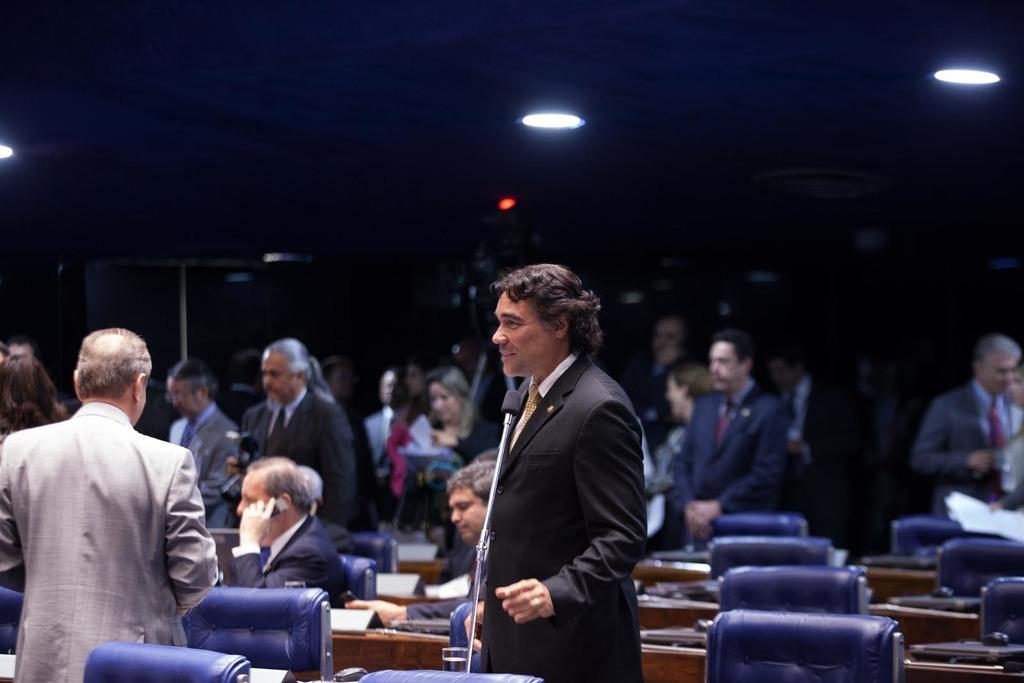How many groups of people can be seen in the image? There are two groups of people in the image, one standing and one sitting. What are the sitting people using to support themselves? The sitting people are on chairs. What objects are present on the tables in front of the sitting people? There are microphones on the tables. What might the people be doing in the image? The presence of microphones suggests that the sitting people might be participating in a discussion or presentation. How many boys are sitting on the edge of the table in the image? There are no boys sitting on the edge of the table in the image. What type of crack can be heard in the background of the image? There is no sound or crack present in the image. 